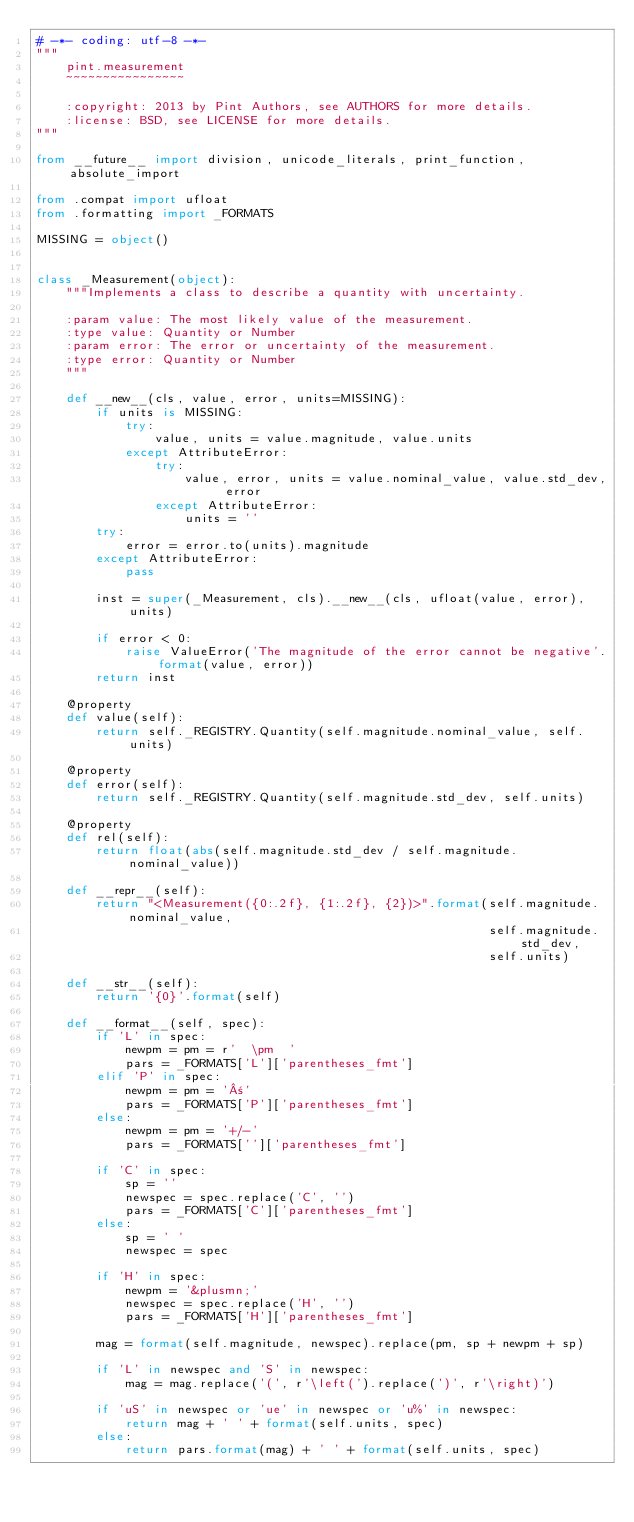Convert code to text. <code><loc_0><loc_0><loc_500><loc_500><_Python_># -*- coding: utf-8 -*-
"""
    pint.measurement
    ~~~~~~~~~~~~~~~~

    :copyright: 2013 by Pint Authors, see AUTHORS for more details.
    :license: BSD, see LICENSE for more details.
"""

from __future__ import division, unicode_literals, print_function, absolute_import

from .compat import ufloat
from .formatting import _FORMATS

MISSING = object()


class _Measurement(object):
    """Implements a class to describe a quantity with uncertainty.

    :param value: The most likely value of the measurement.
    :type value: Quantity or Number
    :param error: The error or uncertainty of the measurement.
    :type error: Quantity or Number
    """

    def __new__(cls, value, error, units=MISSING):
        if units is MISSING:
            try:
                value, units = value.magnitude, value.units
            except AttributeError:
                try:
                    value, error, units = value.nominal_value, value.std_dev, error
                except AttributeError:
                    units = ''
        try:
            error = error.to(units).magnitude
        except AttributeError:
            pass

        inst = super(_Measurement, cls).__new__(cls, ufloat(value, error), units)

        if error < 0:
            raise ValueError('The magnitude of the error cannot be negative'.format(value, error))
        return inst

    @property
    def value(self):
        return self._REGISTRY.Quantity(self.magnitude.nominal_value, self.units)

    @property
    def error(self):
        return self._REGISTRY.Quantity(self.magnitude.std_dev, self.units)

    @property
    def rel(self):
        return float(abs(self.magnitude.std_dev / self.magnitude.nominal_value))

    def __repr__(self):
        return "<Measurement({0:.2f}, {1:.2f}, {2})>".format(self.magnitude.nominal_value,
                                                             self.magnitude.std_dev,
                                                             self.units)

    def __str__(self):
        return '{0}'.format(self)

    def __format__(self, spec):
        if 'L' in spec:
            newpm = pm = r'  \pm  '
            pars = _FORMATS['L']['parentheses_fmt']
        elif 'P' in spec:
            newpm = pm = '±'
            pars = _FORMATS['P']['parentheses_fmt']
        else:
            newpm = pm = '+/-'
            pars = _FORMATS['']['parentheses_fmt']

        if 'C' in spec:
            sp = ''
            newspec = spec.replace('C', '')
            pars = _FORMATS['C']['parentheses_fmt']
        else:
            sp = ' '
            newspec = spec

        if 'H' in spec:
            newpm = '&plusmn;'
            newspec = spec.replace('H', '')
            pars = _FORMATS['H']['parentheses_fmt']

        mag = format(self.magnitude, newspec).replace(pm, sp + newpm + sp)

        if 'L' in newspec and 'S' in newspec:
            mag = mag.replace('(', r'\left(').replace(')', r'\right)')

        if 'uS' in newspec or 'ue' in newspec or 'u%' in newspec:
            return mag + ' ' + format(self.units, spec)
        else:
            return pars.format(mag) + ' ' + format(self.units, spec)
</code> 